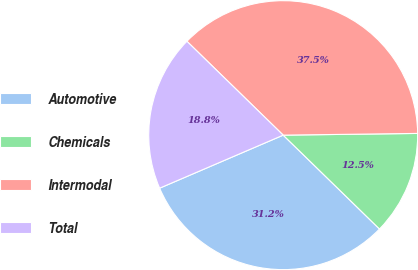Convert chart to OTSL. <chart><loc_0><loc_0><loc_500><loc_500><pie_chart><fcel>Automotive<fcel>Chemicals<fcel>Intermodal<fcel>Total<nl><fcel>31.25%<fcel>12.5%<fcel>37.5%<fcel>18.75%<nl></chart> 